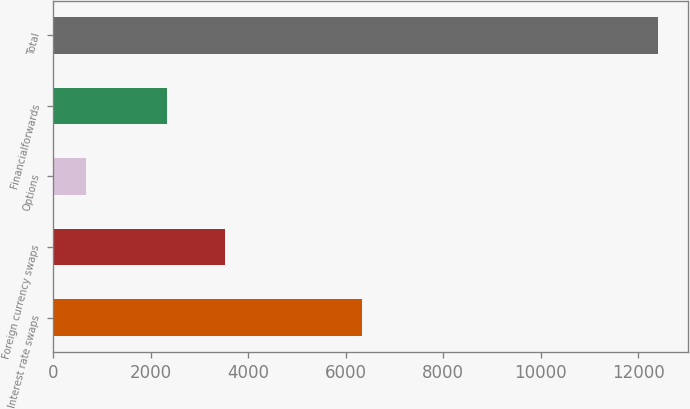<chart> <loc_0><loc_0><loc_500><loc_500><bar_chart><fcel>Interest rate swaps<fcel>Foreign currency swaps<fcel>Options<fcel>Financialforwards<fcel>Total<nl><fcel>6324<fcel>3511.5<fcel>664<fcel>2338<fcel>12399<nl></chart> 